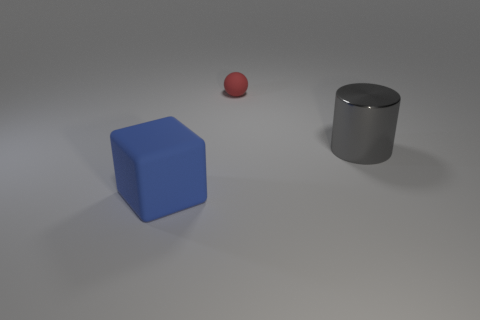What is the material appearance of the blue object? The blue object has a matte appearance, suggesting it could be made of a rubbery or plastic material. 